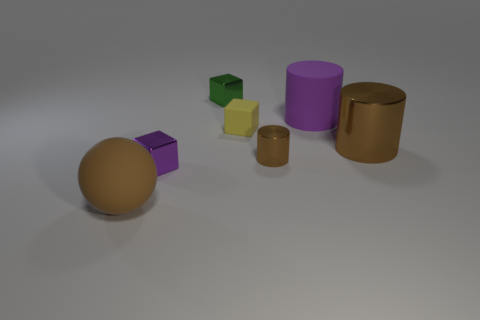There is a small metal object that is behind the matte cylinder; does it have the same shape as the small yellow object that is on the right side of the small purple metal block?
Offer a very short reply. Yes. The large object that is behind the large brown shiny cylinder in front of the cube right of the green metal thing is what color?
Your answer should be very brief. Purple. How many other things are the same color as the small matte block?
Offer a very short reply. 0. Is the number of purple shiny things less than the number of big green shiny cylinders?
Offer a terse response. No. The small thing that is left of the small yellow thing and behind the tiny purple block is what color?
Give a very brief answer. Green. What material is the purple object that is the same shape as the yellow object?
Make the answer very short. Metal. Is there any other thing that has the same size as the yellow matte object?
Offer a very short reply. Yes. Is the number of big purple matte things greater than the number of small purple balls?
Keep it short and to the point. Yes. What size is the matte object that is to the right of the brown rubber ball and in front of the big purple rubber thing?
Provide a succinct answer. Small. The large metal thing is what shape?
Your answer should be very brief. Cylinder. 